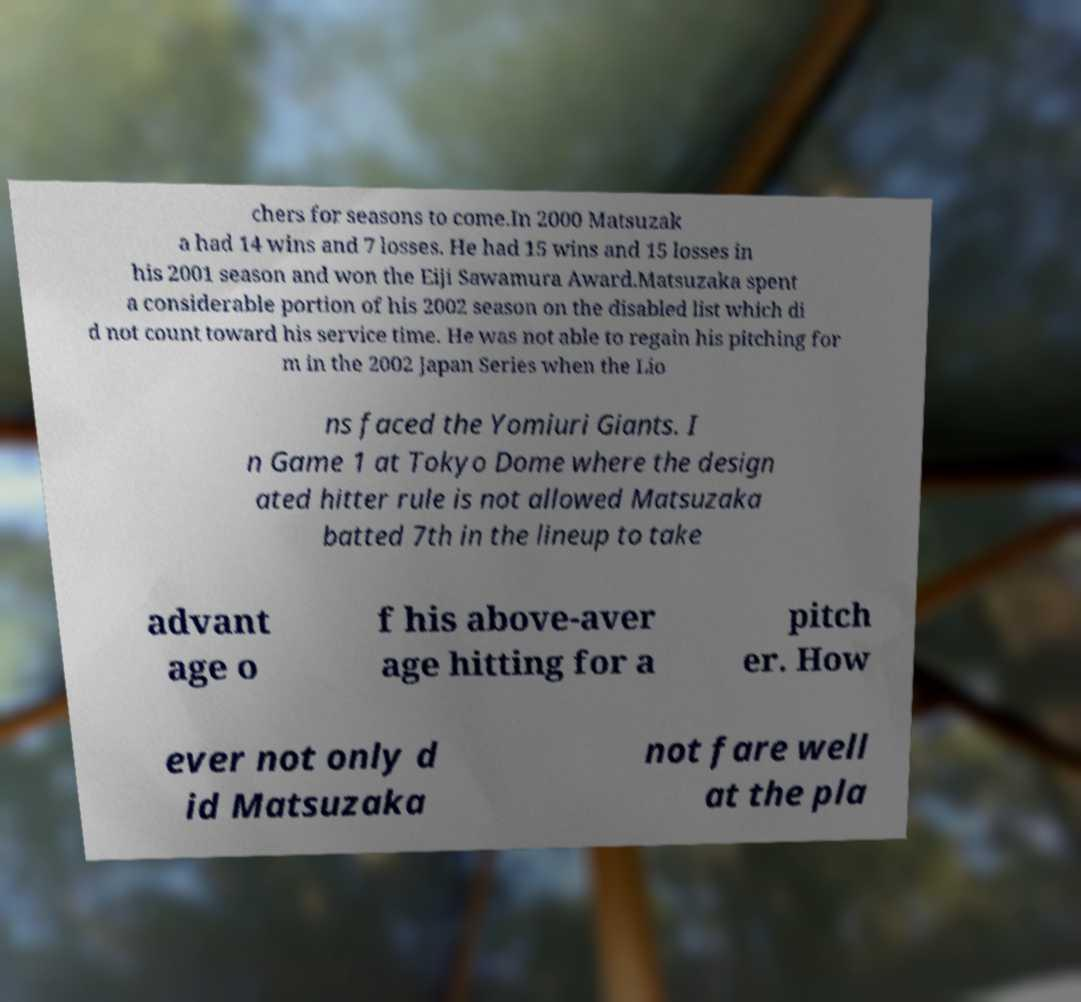Please read and relay the text visible in this image. What does it say? chers for seasons to come.In 2000 Matsuzak a had 14 wins and 7 losses. He had 15 wins and 15 losses in his 2001 season and won the Eiji Sawamura Award.Matsuzaka spent a considerable portion of his 2002 season on the disabled list which di d not count toward his service time. He was not able to regain his pitching for m in the 2002 Japan Series when the Lio ns faced the Yomiuri Giants. I n Game 1 at Tokyo Dome where the design ated hitter rule is not allowed Matsuzaka batted 7th in the lineup to take advant age o f his above-aver age hitting for a pitch er. How ever not only d id Matsuzaka not fare well at the pla 